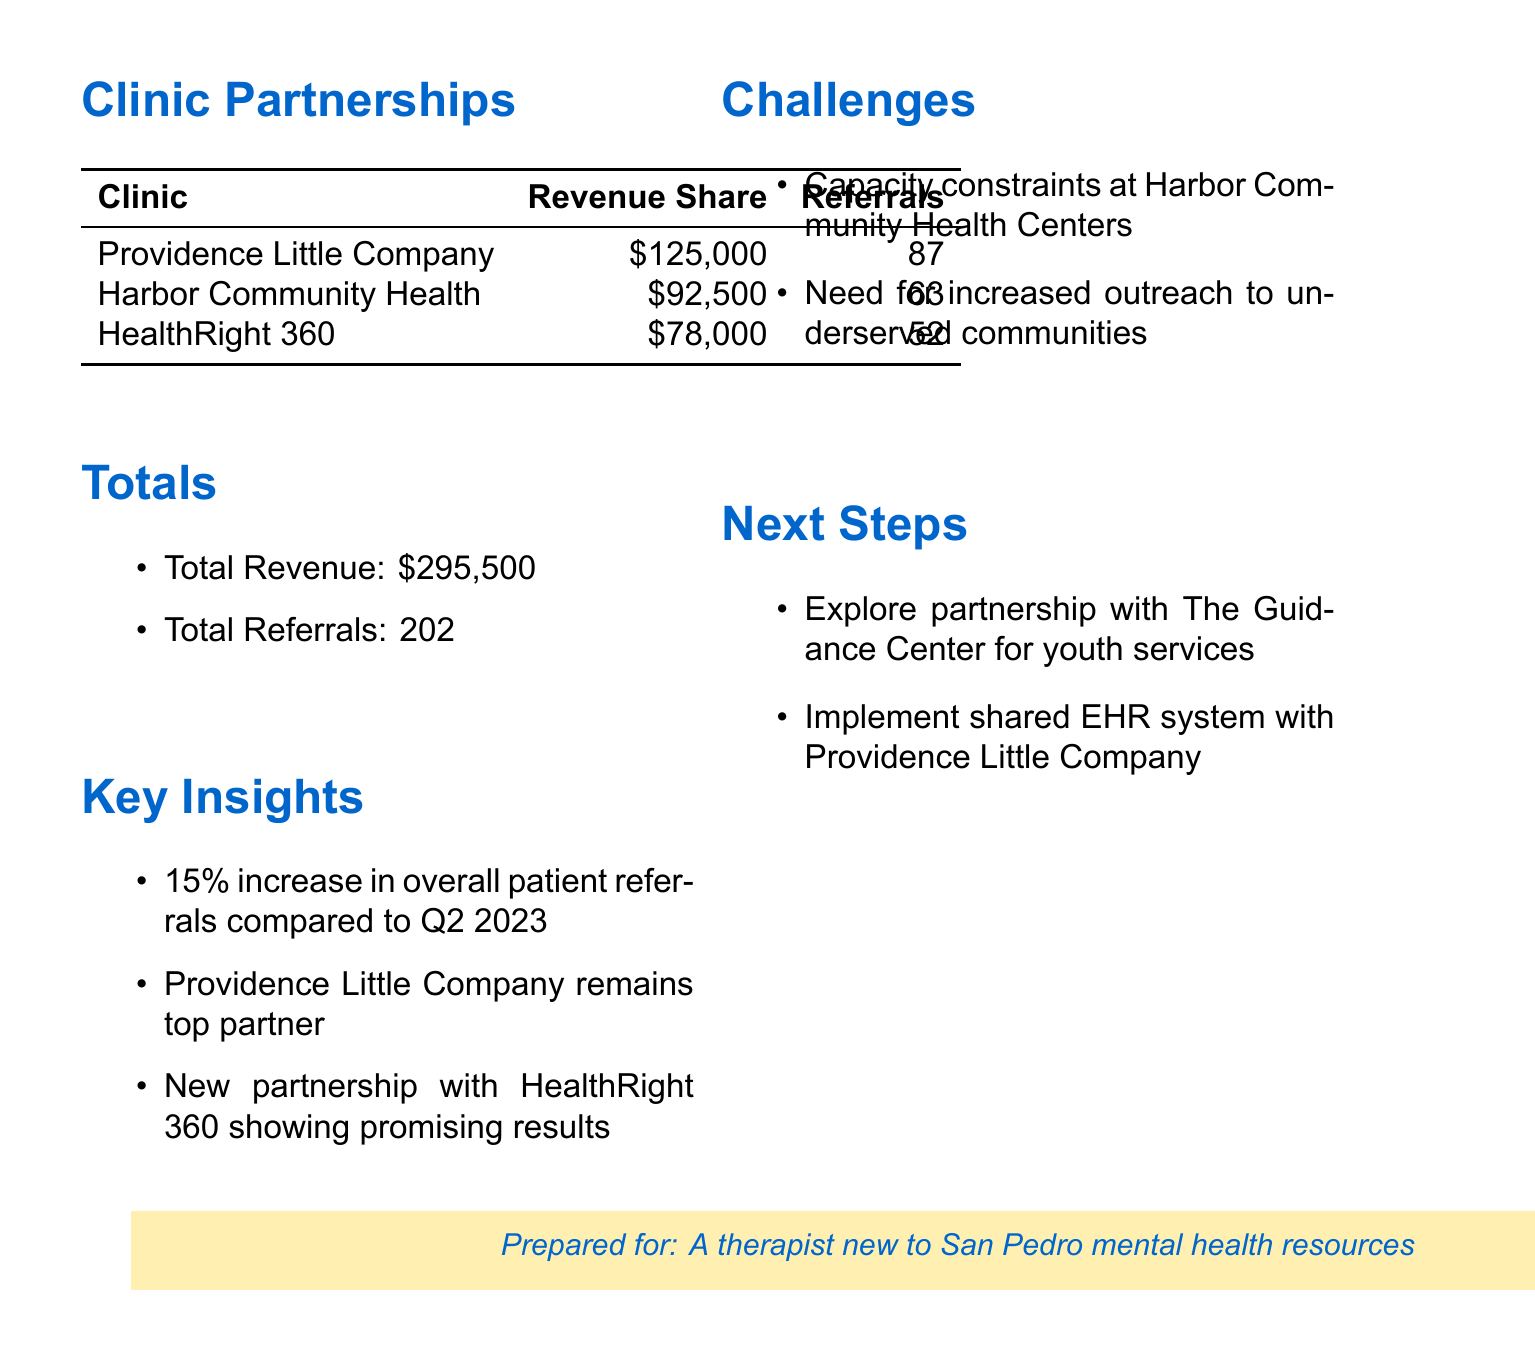What is the total revenue? The total revenue is listed in the document as the sum of revenue from all partnerships, which is $295,500.
Answer: $295,500 How many total patient referrals were made? The total referrals are provided in the document, summing up to 202.
Answer: 202 Which clinic had the highest revenue share? The clinic with the highest revenue share is identified in the document as Providence Little Company of Mary Medical Center San Pedro with $125,000.
Answer: Providence Little Company of Mary Medical Center San Pedro What percentage increase in referrals was noted compared to Q2 2023? The document states there was a 15% increase in overall patient referrals compared to the previous quarter.
Answer: 15% What challenge is mentioned regarding Harbor Community Health Centers? The document highlights the capacity constraints at Harbor Community Health Centers as a challenge affecting potential referrals.
Answer: Capacity constraints What is one of the next steps for the clinics mentioned in the report? The document indicates exploring a partnership with The Guidance Center for youth mental health services as a next step.
Answer: Explore partnership with The Guidance Center How many patient referrals did HealthRight 360 make? The number of patient referrals made by HealthRight 360 is specified as 52 in the document.
Answer: 52 What is the Revenue Share for Harbor Community Health Centers? The Revenue Share for Harbor Community Health Centers is provided as $92,500 in the document.
Answer: $92,500 